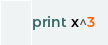Convert code to text. <code><loc_0><loc_0><loc_500><loc_500><_Python_>print x^3</code> 